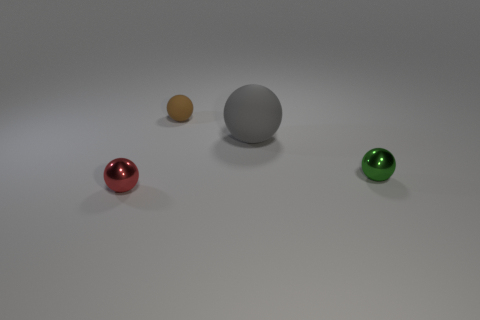Is the shape of the object that is left of the small brown rubber thing the same as the gray object? The object left of the small brown item, which appears to be a sphere similar to the other colorful objects, has the same spherical shape as the gray object in the center. 